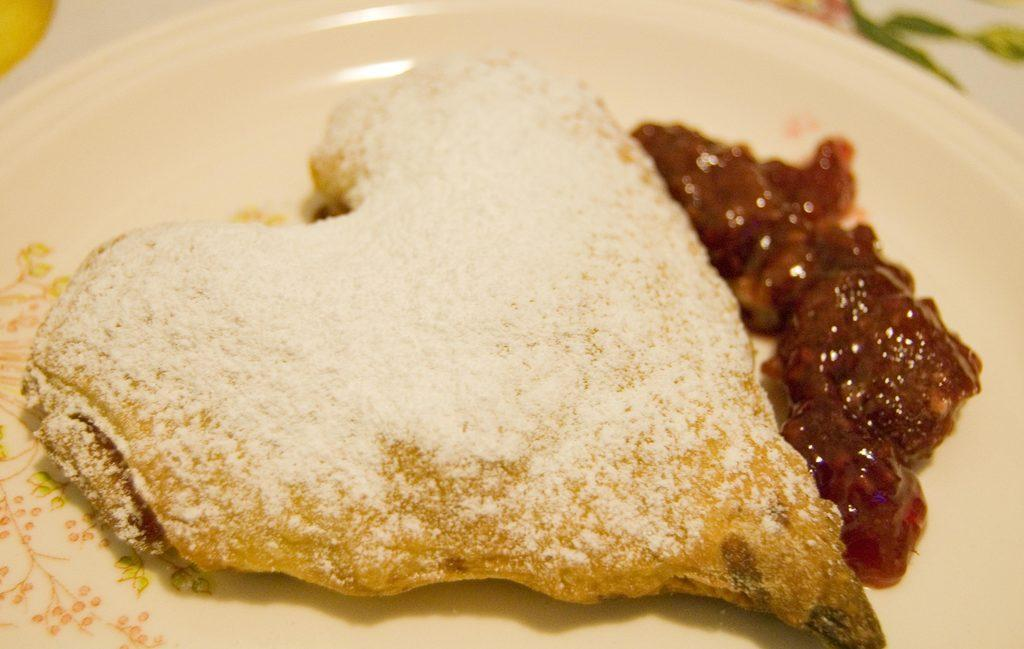What is present on the plate in the image? The plate has food on it. What type of animal can be seen wearing a hat in the image? There is no animal or hat present in the image; it only features a plate with food on it. 